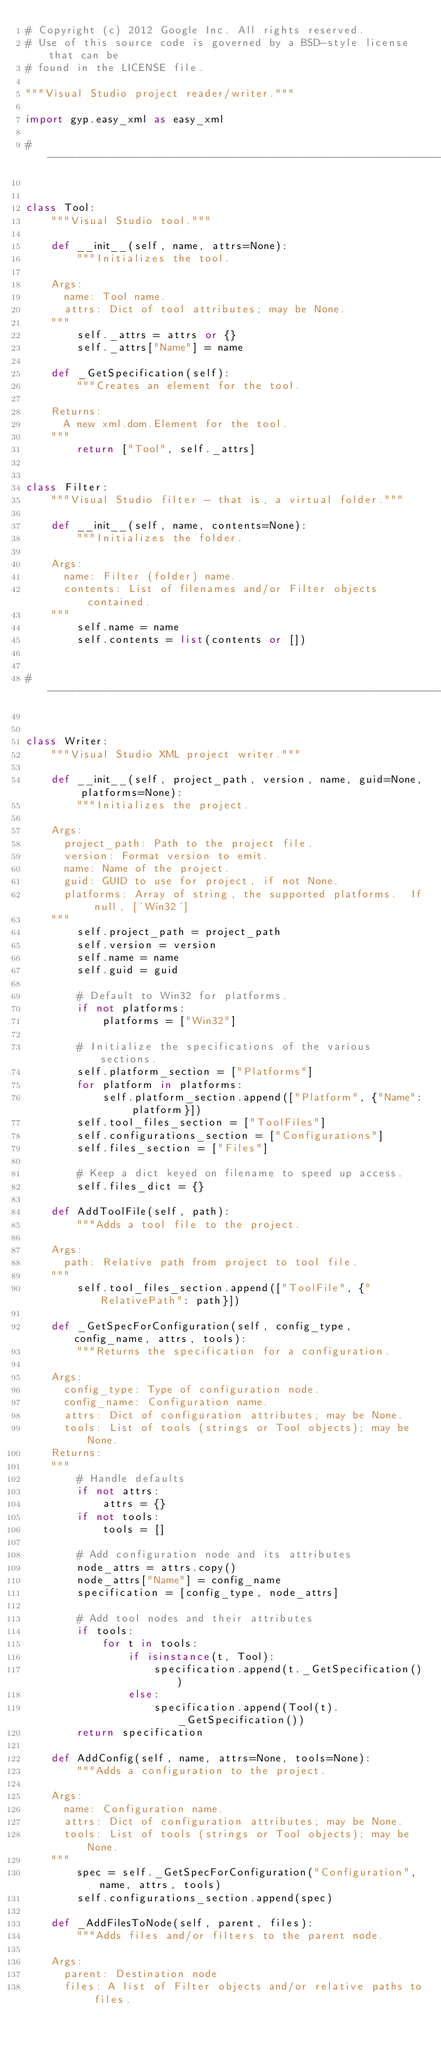Convert code to text. <code><loc_0><loc_0><loc_500><loc_500><_Python_># Copyright (c) 2012 Google Inc. All rights reserved.
# Use of this source code is governed by a BSD-style license that can be
# found in the LICENSE file.

"""Visual Studio project reader/writer."""

import gyp.easy_xml as easy_xml

# ------------------------------------------------------------------------------


class Tool:
    """Visual Studio tool."""

    def __init__(self, name, attrs=None):
        """Initializes the tool.

    Args:
      name: Tool name.
      attrs: Dict of tool attributes; may be None.
    """
        self._attrs = attrs or {}
        self._attrs["Name"] = name

    def _GetSpecification(self):
        """Creates an element for the tool.

    Returns:
      A new xml.dom.Element for the tool.
    """
        return ["Tool", self._attrs]


class Filter:
    """Visual Studio filter - that is, a virtual folder."""

    def __init__(self, name, contents=None):
        """Initializes the folder.

    Args:
      name: Filter (folder) name.
      contents: List of filenames and/or Filter objects contained.
    """
        self.name = name
        self.contents = list(contents or [])


# ------------------------------------------------------------------------------


class Writer:
    """Visual Studio XML project writer."""

    def __init__(self, project_path, version, name, guid=None, platforms=None):
        """Initializes the project.

    Args:
      project_path: Path to the project file.
      version: Format version to emit.
      name: Name of the project.
      guid: GUID to use for project, if not None.
      platforms: Array of string, the supported platforms.  If null, ['Win32']
    """
        self.project_path = project_path
        self.version = version
        self.name = name
        self.guid = guid

        # Default to Win32 for platforms.
        if not platforms:
            platforms = ["Win32"]

        # Initialize the specifications of the various sections.
        self.platform_section = ["Platforms"]
        for platform in platforms:
            self.platform_section.append(["Platform", {"Name": platform}])
        self.tool_files_section = ["ToolFiles"]
        self.configurations_section = ["Configurations"]
        self.files_section = ["Files"]

        # Keep a dict keyed on filename to speed up access.
        self.files_dict = {}

    def AddToolFile(self, path):
        """Adds a tool file to the project.

    Args:
      path: Relative path from project to tool file.
    """
        self.tool_files_section.append(["ToolFile", {"RelativePath": path}])

    def _GetSpecForConfiguration(self, config_type, config_name, attrs, tools):
        """Returns the specification for a configuration.

    Args:
      config_type: Type of configuration node.
      config_name: Configuration name.
      attrs: Dict of configuration attributes; may be None.
      tools: List of tools (strings or Tool objects); may be None.
    Returns:
    """
        # Handle defaults
        if not attrs:
            attrs = {}
        if not tools:
            tools = []

        # Add configuration node and its attributes
        node_attrs = attrs.copy()
        node_attrs["Name"] = config_name
        specification = [config_type, node_attrs]

        # Add tool nodes and their attributes
        if tools:
            for t in tools:
                if isinstance(t, Tool):
                    specification.append(t._GetSpecification())
                else:
                    specification.append(Tool(t)._GetSpecification())
        return specification

    def AddConfig(self, name, attrs=None, tools=None):
        """Adds a configuration to the project.

    Args:
      name: Configuration name.
      attrs: Dict of configuration attributes; may be None.
      tools: List of tools (strings or Tool objects); may be None.
    """
        spec = self._GetSpecForConfiguration("Configuration", name, attrs, tools)
        self.configurations_section.append(spec)

    def _AddFilesToNode(self, parent, files):
        """Adds files and/or filters to the parent node.

    Args:
      parent: Destination node
      files: A list of Filter objects and/or relative paths to files.
</code> 